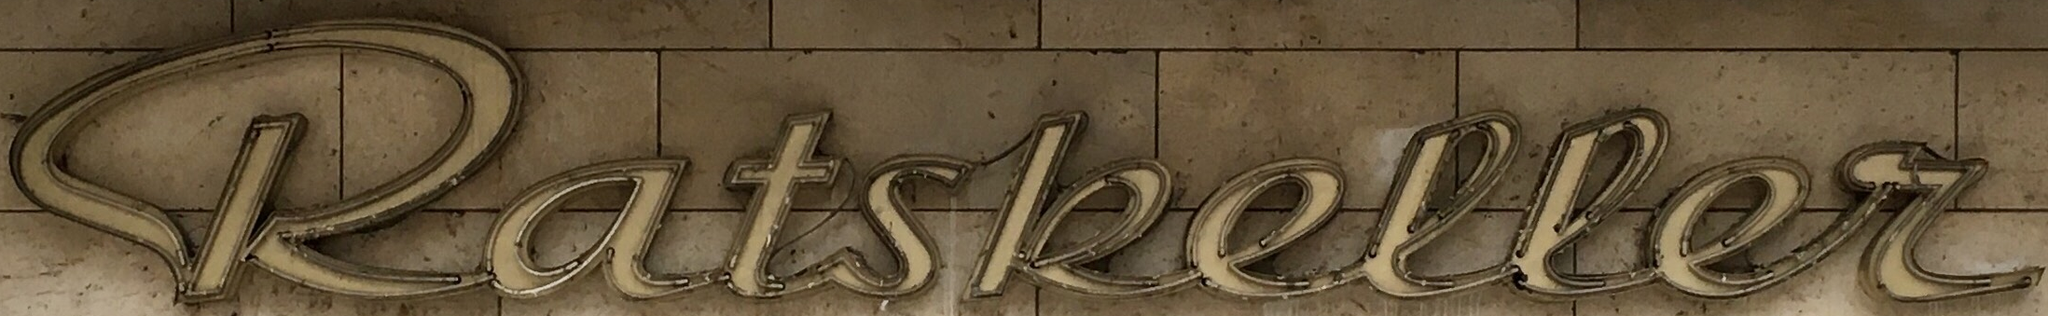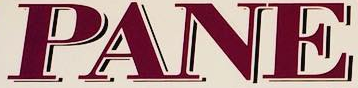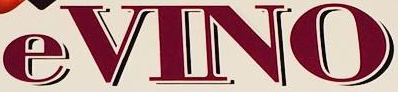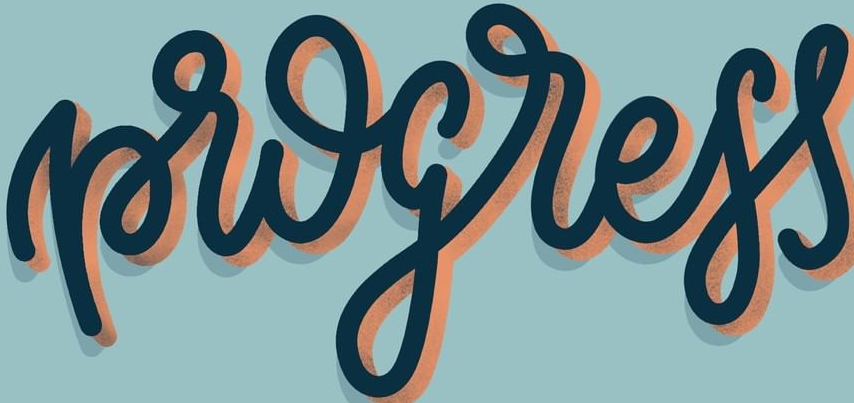Read the text from these images in sequence, separated by a semicolon. katskeller; PANE; eVINO; progress 